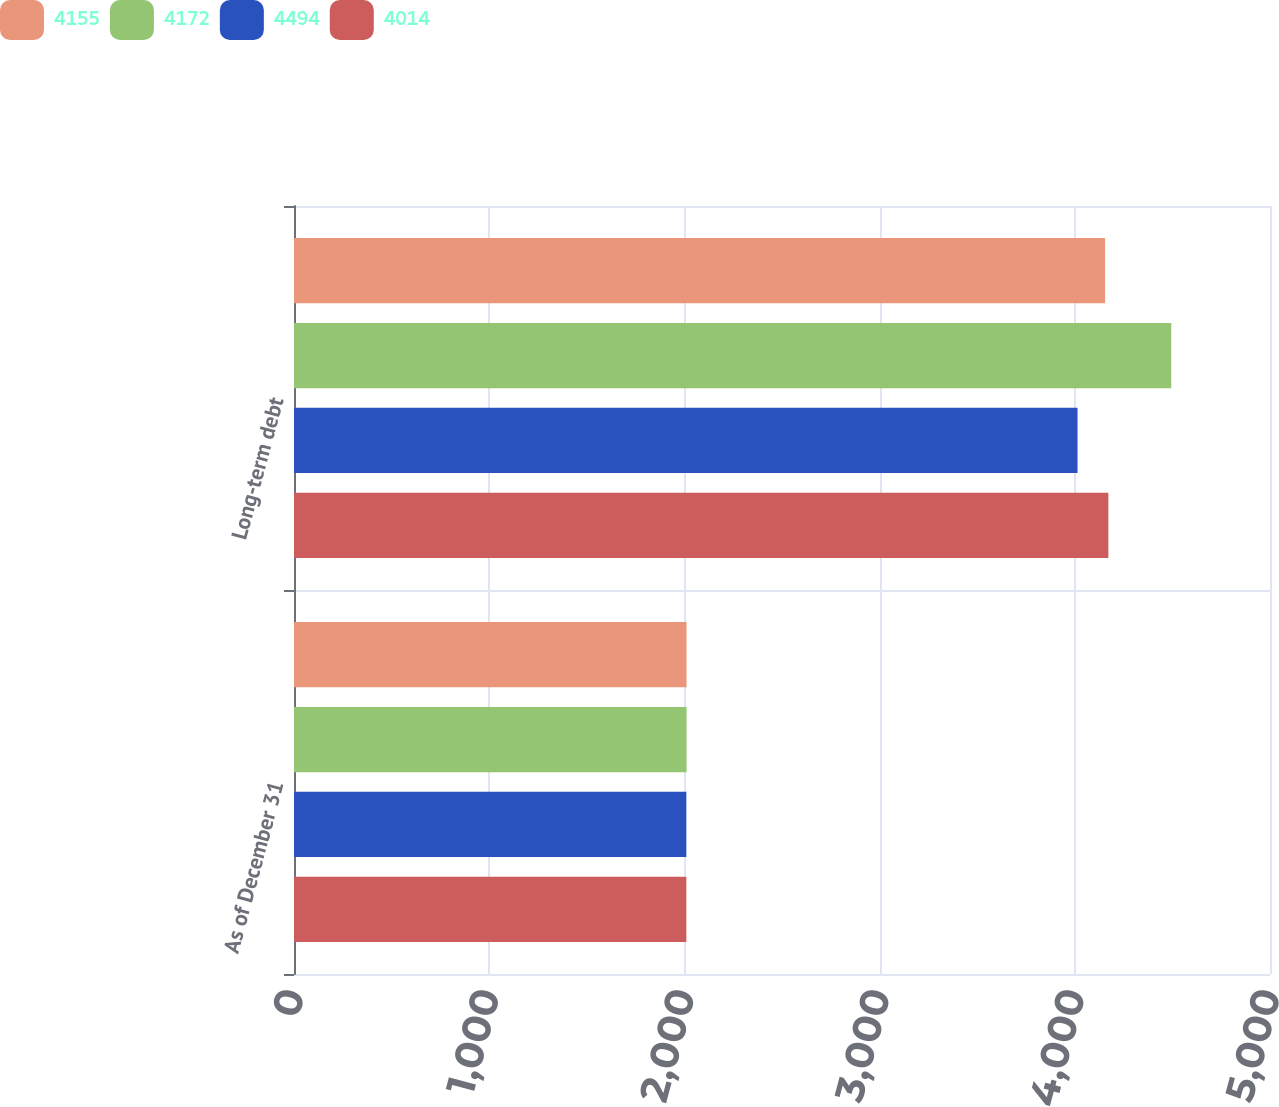Convert chart. <chart><loc_0><loc_0><loc_500><loc_500><stacked_bar_chart><ecel><fcel>As of December 31<fcel>Long-term debt<nl><fcel>4155<fcel>2011<fcel>4155<nl><fcel>4172<fcel>2011<fcel>4494<nl><fcel>4494<fcel>2010<fcel>4014<nl><fcel>4014<fcel>2010<fcel>4172<nl></chart> 